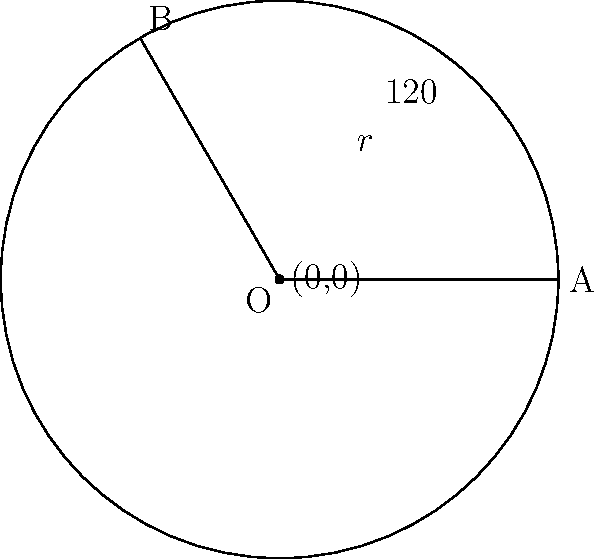In the Martian invasion, a circular force field with radius $r = 300$ meters is deployed to protect a group of survivors. If the central angle of the sector they occupy is $120°$, what is the area of the sector in square meters? Round your answer to the nearest whole number. To find the area of a circular sector, we can use the formula:

$$A = \frac{\theta}{360°} \cdot \pi r^2$$

Where:
$A$ is the area of the sector
$\theta$ is the central angle in degrees
$r$ is the radius of the circle

Given:
$\theta = 120°$
$r = 300$ meters

Step 1: Substitute the values into the formula:
$$A = \frac{120°}{360°} \cdot \pi (300)^2$$

Step 2: Simplify the fraction:
$$A = \frac{1}{3} \cdot \pi (300)^2$$

Step 3: Calculate $\pi (300)^2$:
$$A = \frac{1}{3} \cdot \pi \cdot 90,000$$

Step 4: Multiply:
$$A = 94,247.78... \text{ square meters}$$

Step 5: Round to the nearest whole number:
$$A \approx 94,248 \text{ square meters}$$
Answer: 94,248 square meters 